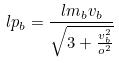<formula> <loc_0><loc_0><loc_500><loc_500>l p _ { b } = \frac { l m _ { b } v _ { b } } { \sqrt { 3 + \frac { v _ { b } ^ { 2 } } { o ^ { 2 } } } }</formula> 